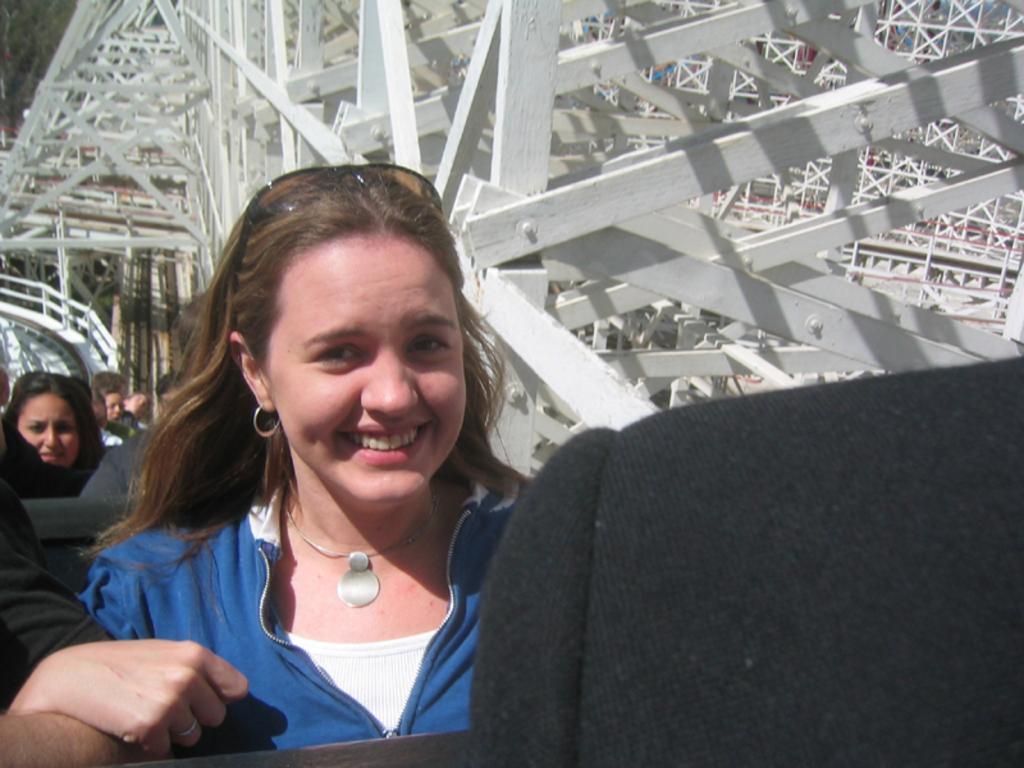Could you give a brief overview of what you see in this image? In this image we can see some people sitting in the seats. On the backside we can see the metal frames. 